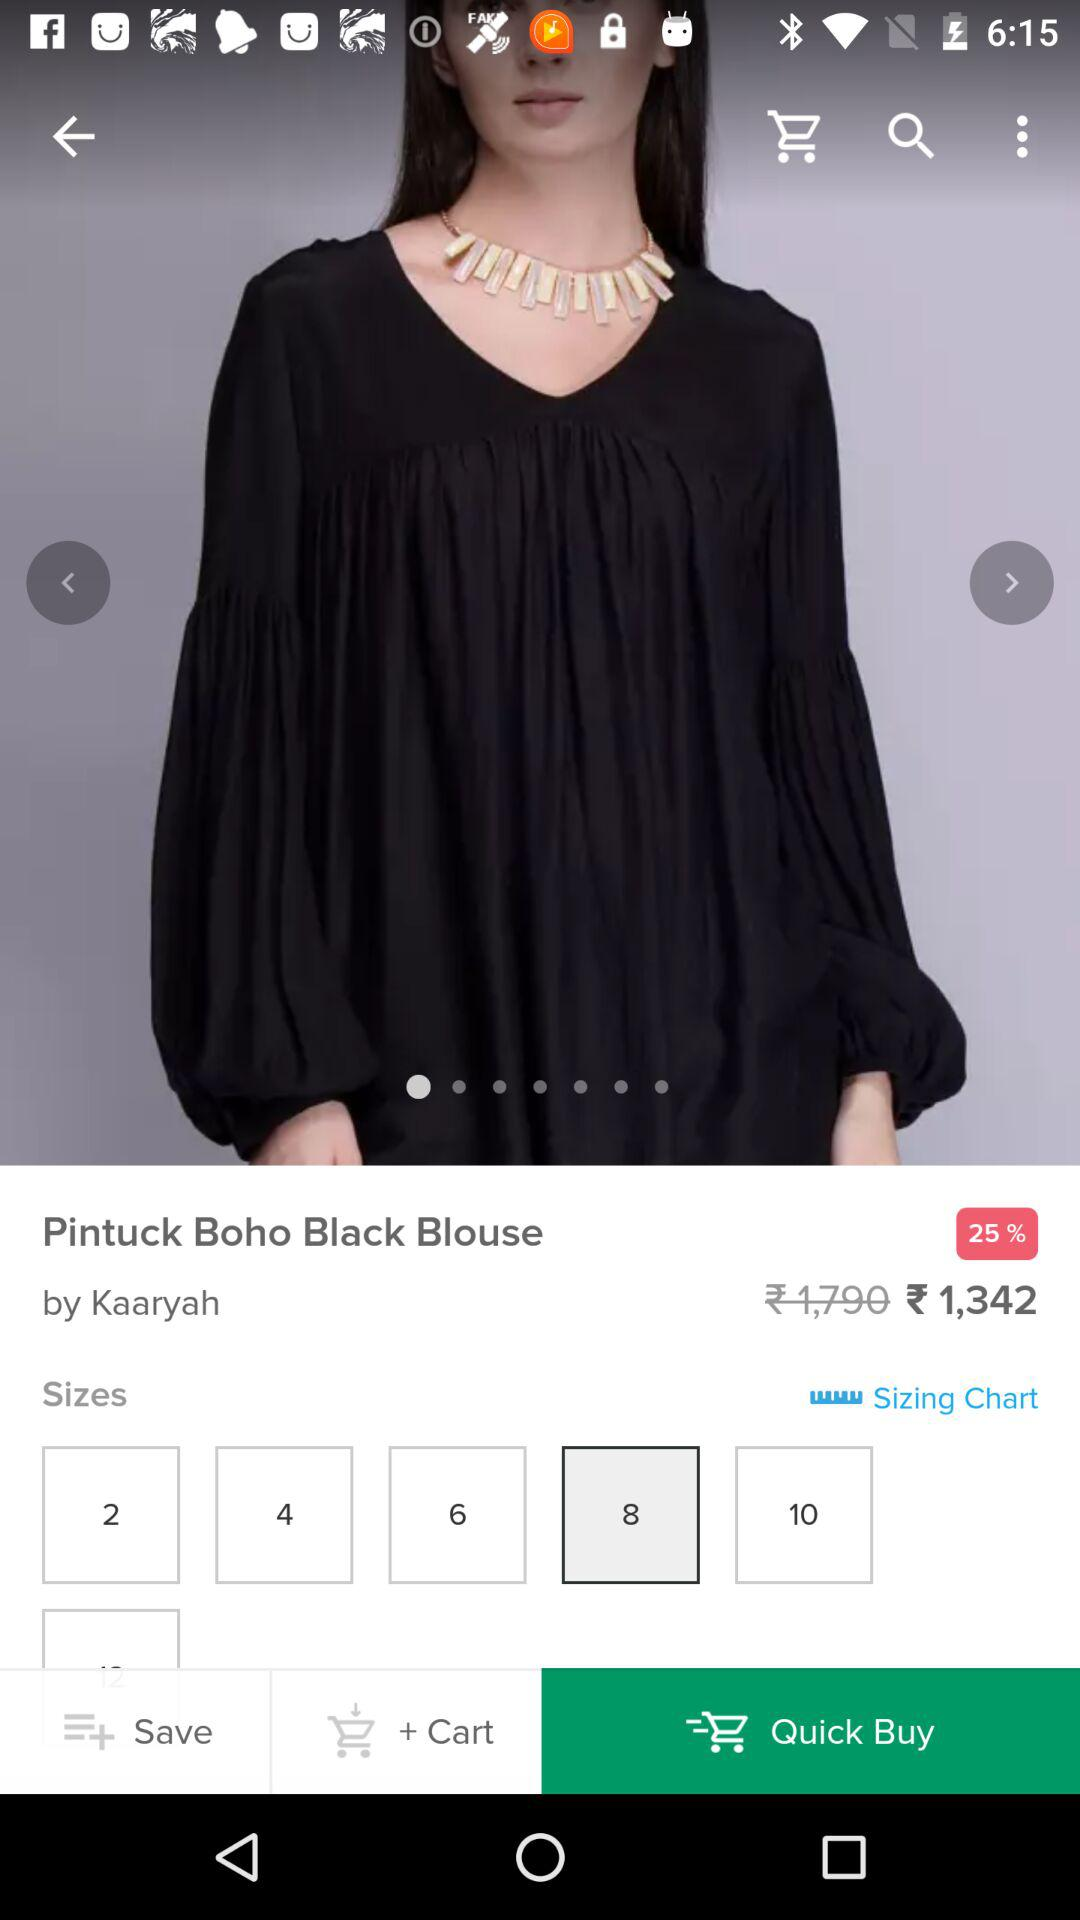What is the discounted price of the "Pintuck Boho Black Blouse"? The discounted price of the "Pintuck Boho Black Blouse" is 1,342 rupees. 